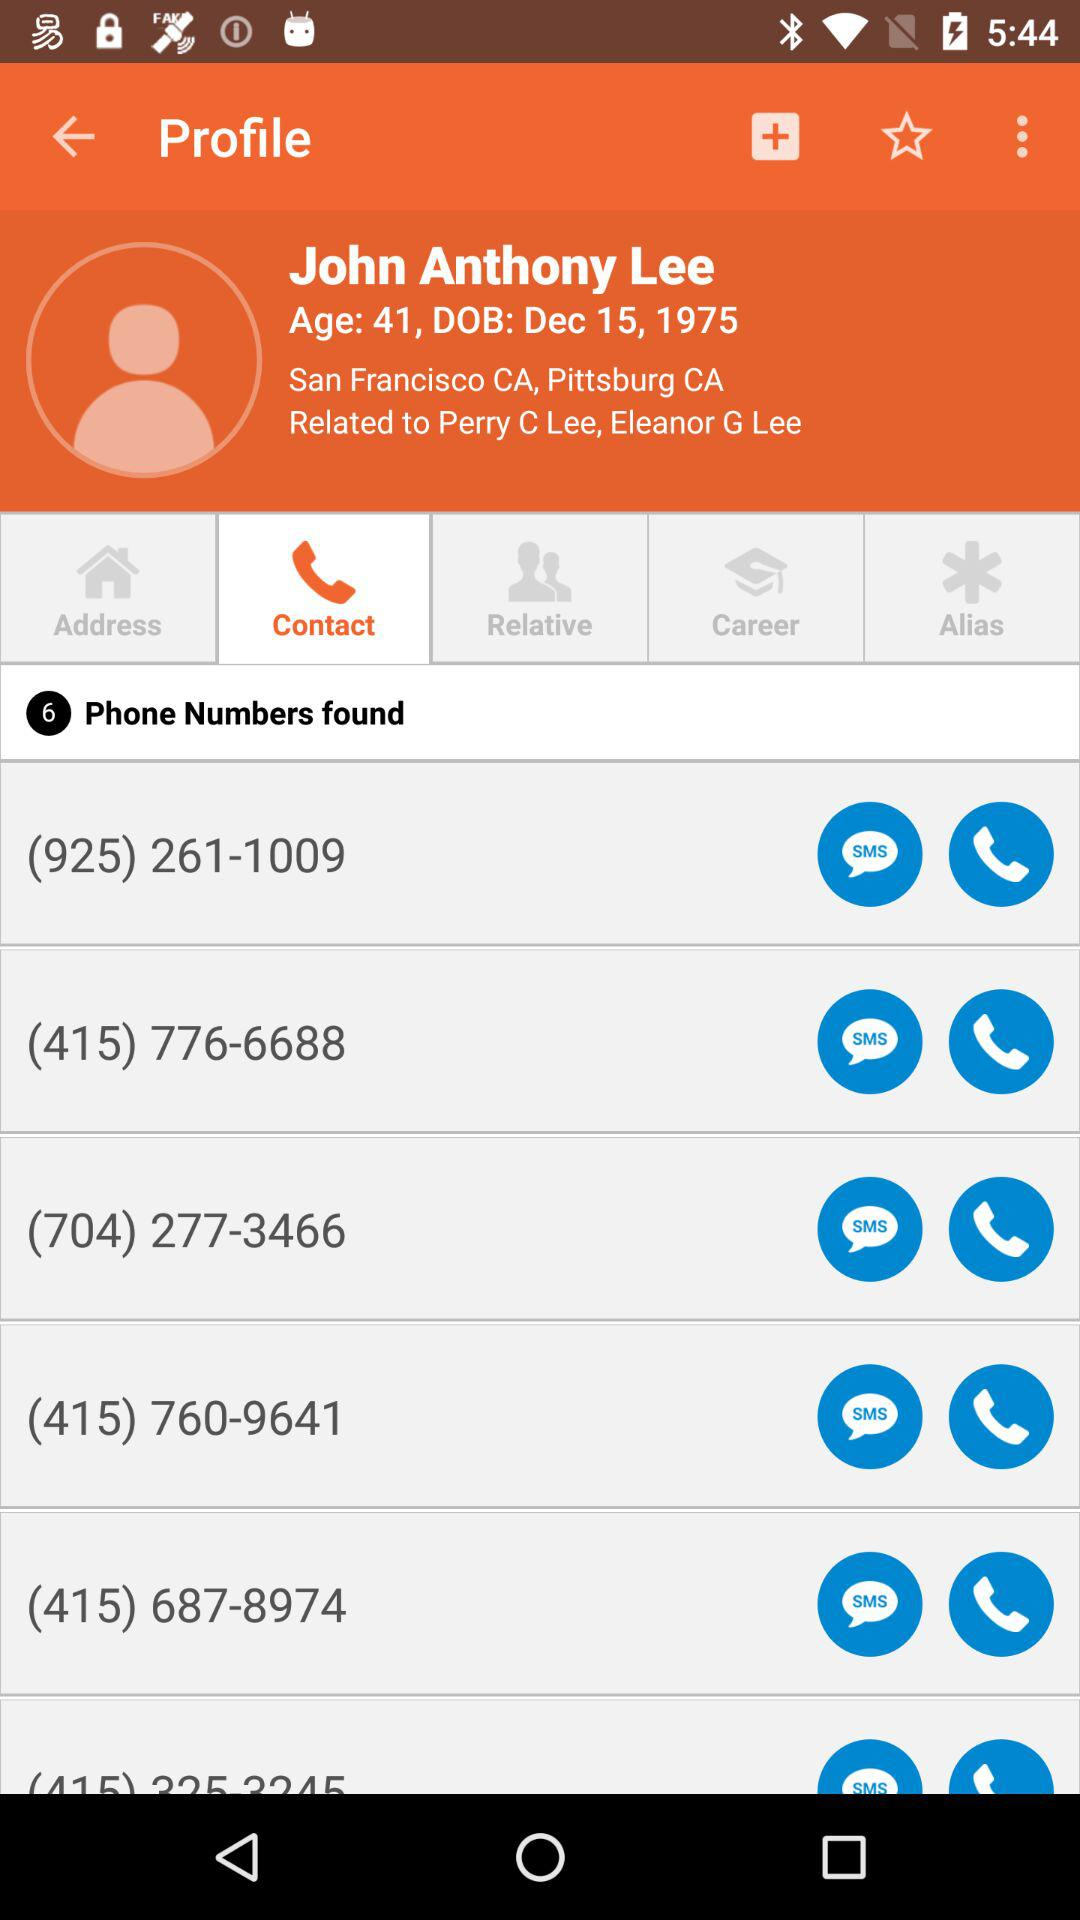How many phone numbers does John Anthony Lee have?
Answer the question using a single word or phrase. 6 